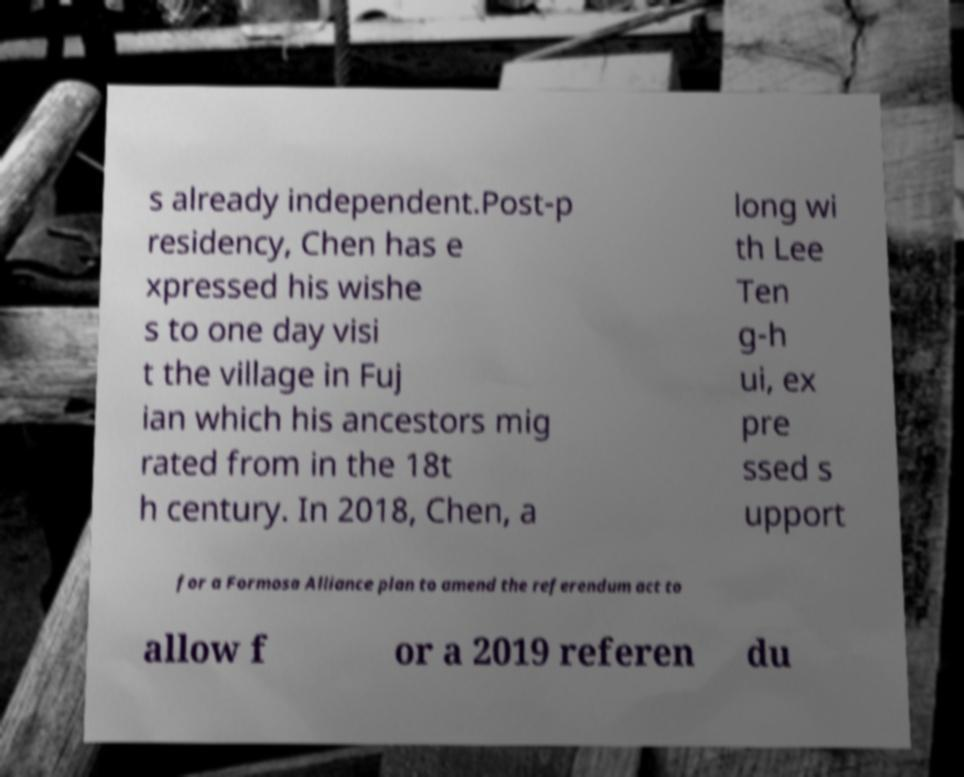Please read and relay the text visible in this image. What does it say? s already independent.Post-p residency, Chen has e xpressed his wishe s to one day visi t the village in Fuj ian which his ancestors mig rated from in the 18t h century. In 2018, Chen, a long wi th Lee Ten g-h ui, ex pre ssed s upport for a Formosa Alliance plan to amend the referendum act to allow f or a 2019 referen du 